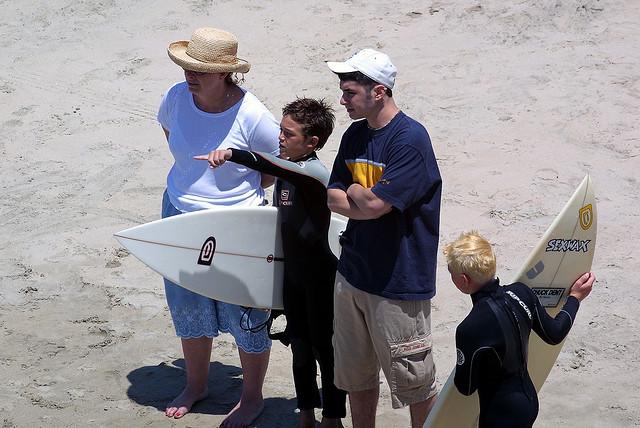How many children are in the image?
Write a very short answer. 2. How many people are dressed for surfing?
Quick response, please. 2. Are the two hats the same?
Be succinct. No. 